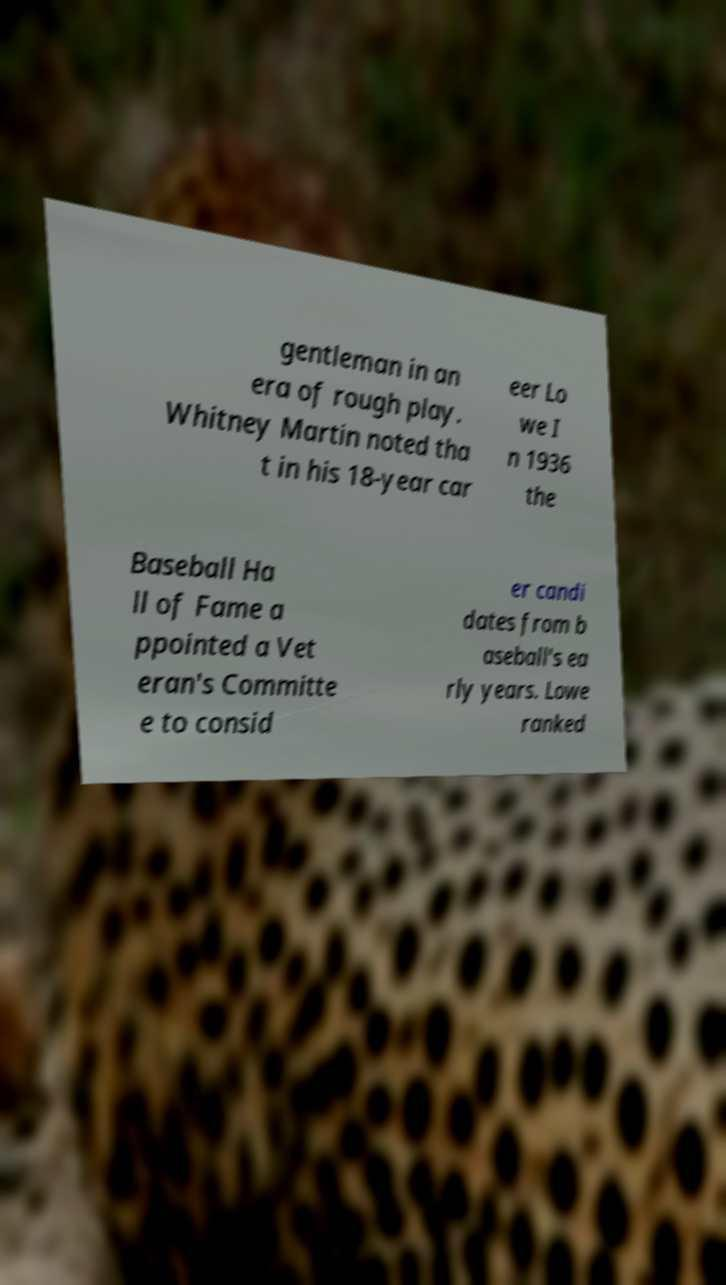I need the written content from this picture converted into text. Can you do that? gentleman in an era of rough play. Whitney Martin noted tha t in his 18-year car eer Lo we I n 1936 the Baseball Ha ll of Fame a ppointed a Vet eran's Committe e to consid er candi dates from b aseball's ea rly years. Lowe ranked 